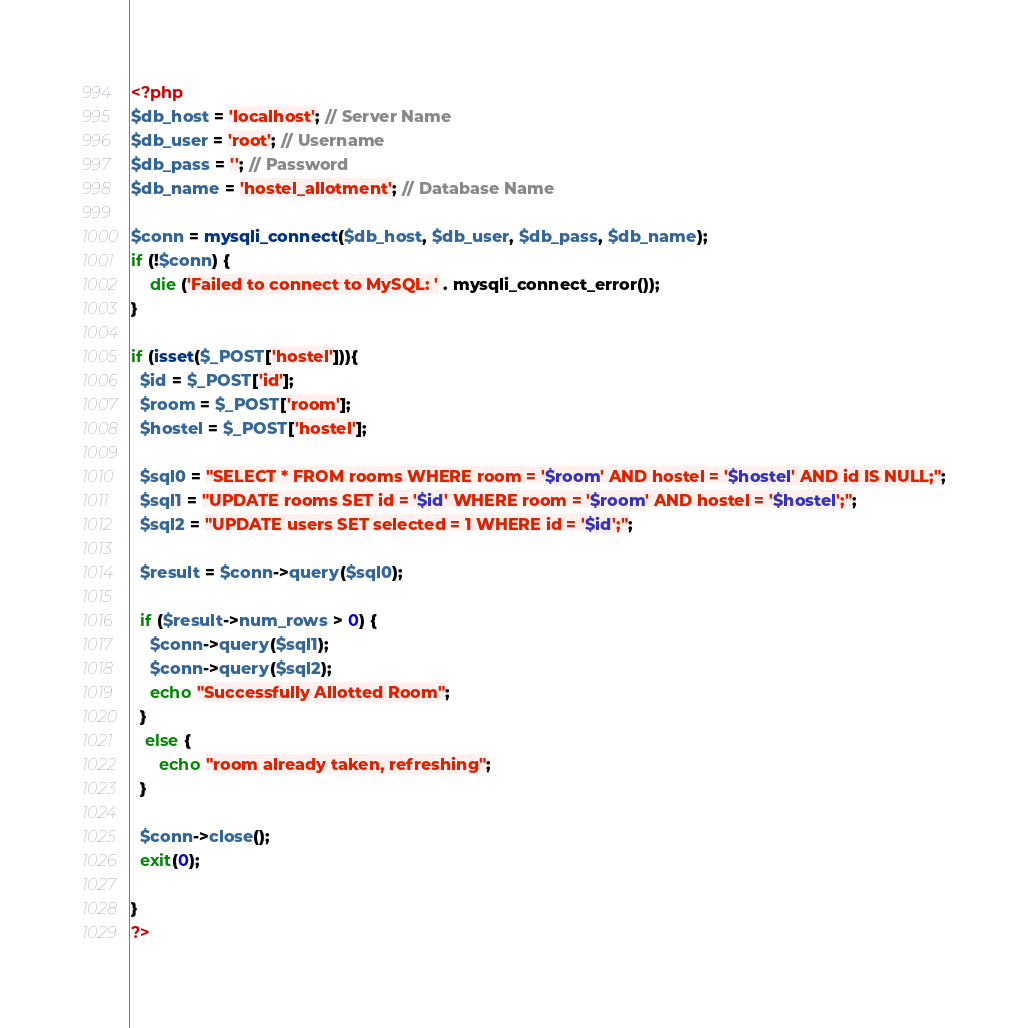Convert code to text. <code><loc_0><loc_0><loc_500><loc_500><_PHP_><?php
$db_host = 'localhost'; // Server Name
$db_user = 'root'; // Username
$db_pass = ''; // Password
$db_name = 'hostel_allotment'; // Database Name

$conn = mysqli_connect($db_host, $db_user, $db_pass, $db_name);
if (!$conn) {
	die ('Failed to connect to MySQL: ' . mysqli_connect_error());
}

if (isset($_POST['hostel'])){
  $id = $_POST['id'];
  $room = $_POST['room'];
  $hostel = $_POST['hostel'];

  $sql0 = "SELECT * FROM rooms WHERE room = '$room' AND hostel = '$hostel' AND id IS NULL;";
  $sql1 = "UPDATE rooms SET id = '$id' WHERE room = '$room' AND hostel = '$hostel';";
  $sql2 = "UPDATE users SET selected = 1 WHERE id = '$id';";

  $result = $conn->query($sql0);

  if ($result->num_rows > 0) {
    $conn->query($sql1);
    $conn->query($sql2);
    echo "Successfully Allotted Room";
  }
   else {
      echo "room already taken, refreshing";
  }

  $conn->close();
  exit(0);

}
?>
</code> 